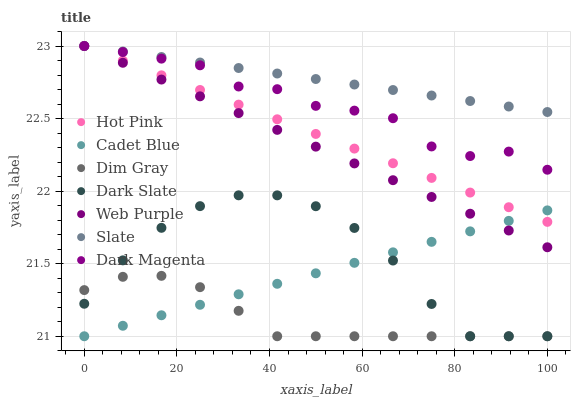Does Dim Gray have the minimum area under the curve?
Answer yes or no. Yes. Does Slate have the maximum area under the curve?
Answer yes or no. Yes. Does Dark Magenta have the minimum area under the curve?
Answer yes or no. No. Does Dark Magenta have the maximum area under the curve?
Answer yes or no. No. Is Slate the smoothest?
Answer yes or no. Yes. Is Dark Magenta the roughest?
Answer yes or no. Yes. Is Dark Magenta the smoothest?
Answer yes or no. No. Is Slate the roughest?
Answer yes or no. No. Does Cadet Blue have the lowest value?
Answer yes or no. Yes. Does Dark Magenta have the lowest value?
Answer yes or no. No. Does Web Purple have the highest value?
Answer yes or no. Yes. Does Dark Slate have the highest value?
Answer yes or no. No. Is Dark Slate less than Dark Magenta?
Answer yes or no. Yes. Is Slate greater than Cadet Blue?
Answer yes or no. Yes. Does Web Purple intersect Slate?
Answer yes or no. Yes. Is Web Purple less than Slate?
Answer yes or no. No. Is Web Purple greater than Slate?
Answer yes or no. No. Does Dark Slate intersect Dark Magenta?
Answer yes or no. No. 